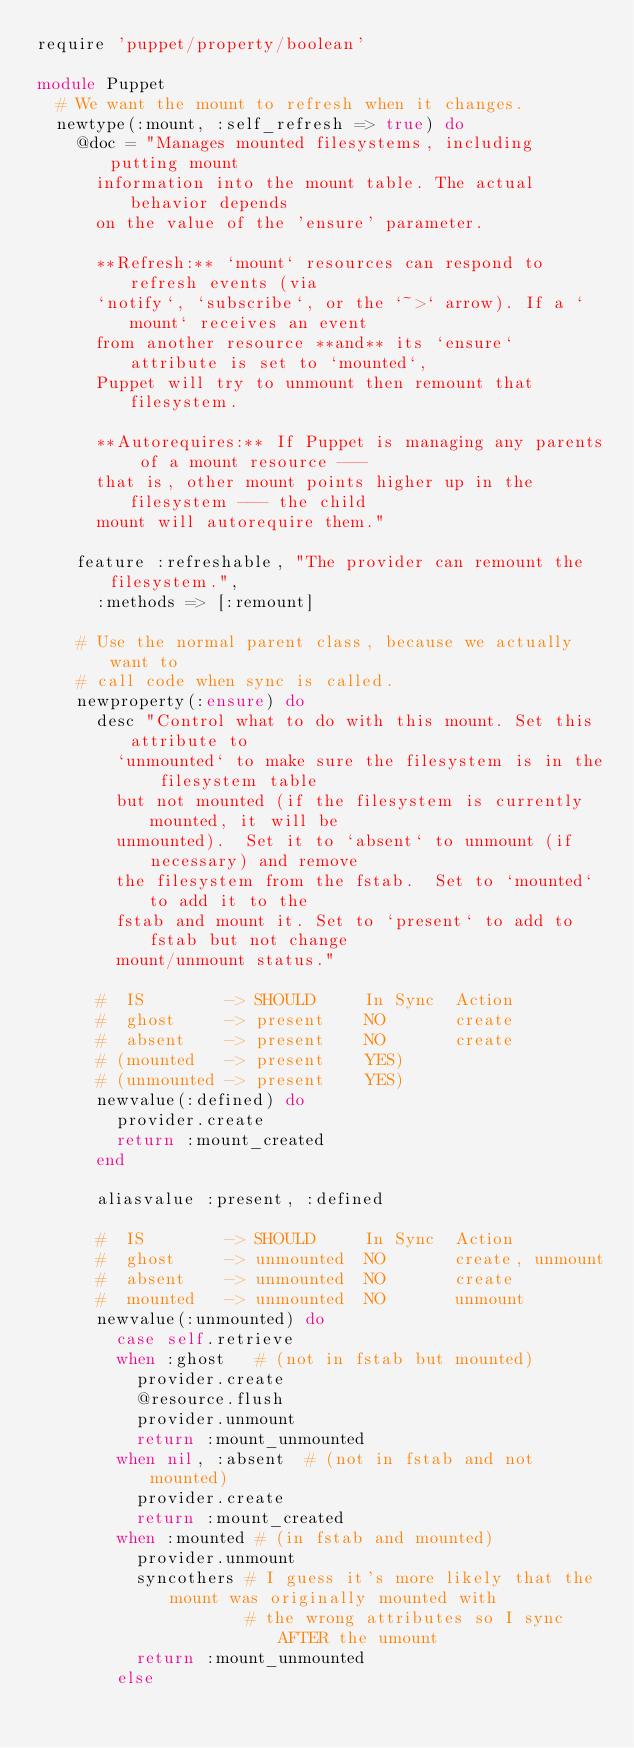Convert code to text. <code><loc_0><loc_0><loc_500><loc_500><_Ruby_>require 'puppet/property/boolean'

module Puppet
  # We want the mount to refresh when it changes.
  newtype(:mount, :self_refresh => true) do
    @doc = "Manages mounted filesystems, including putting mount
      information into the mount table. The actual behavior depends
      on the value of the 'ensure' parameter.

      **Refresh:** `mount` resources can respond to refresh events (via
      `notify`, `subscribe`, or the `~>` arrow). If a `mount` receives an event
      from another resource **and** its `ensure` attribute is set to `mounted`,
      Puppet will try to unmount then remount that filesystem.

      **Autorequires:** If Puppet is managing any parents of a mount resource ---
      that is, other mount points higher up in the filesystem --- the child
      mount will autorequire them."

    feature :refreshable, "The provider can remount the filesystem.",
      :methods => [:remount]

    # Use the normal parent class, because we actually want to
    # call code when sync is called.
    newproperty(:ensure) do
      desc "Control what to do with this mount. Set this attribute to
        `unmounted` to make sure the filesystem is in the filesystem table
        but not mounted (if the filesystem is currently mounted, it will be
        unmounted).  Set it to `absent` to unmount (if necessary) and remove
        the filesystem from the fstab.  Set to `mounted` to add it to the
        fstab and mount it. Set to `present` to add to fstab but not change
        mount/unmount status."

      #  IS        -> SHOULD     In Sync  Action
      #  ghost     -> present    NO       create
      #  absent    -> present    NO       create
      # (mounted   -> present    YES)
      # (unmounted -> present    YES)
      newvalue(:defined) do
        provider.create
        return :mount_created
      end

      aliasvalue :present, :defined

      #  IS        -> SHOULD     In Sync  Action
      #  ghost     -> unmounted  NO       create, unmount
      #  absent    -> unmounted  NO       create
      #  mounted   -> unmounted  NO       unmount
      newvalue(:unmounted) do
        case self.retrieve
        when :ghost   # (not in fstab but mounted)
          provider.create
          @resource.flush
          provider.unmount
          return :mount_unmounted
        when nil, :absent  # (not in fstab and not mounted)
          provider.create
          return :mount_created
        when :mounted # (in fstab and mounted)
          provider.unmount
          syncothers # I guess it's more likely that the mount was originally mounted with
                     # the wrong attributes so I sync AFTER the umount
          return :mount_unmounted
        else</code> 